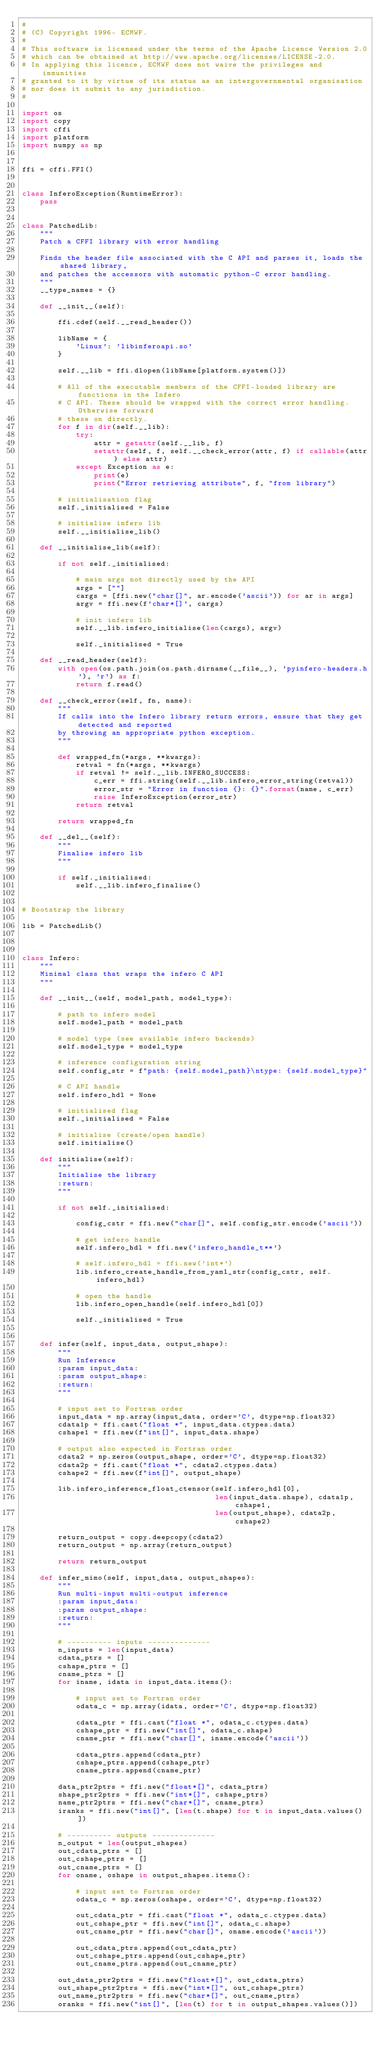<code> <loc_0><loc_0><loc_500><loc_500><_Python_>#
# (C) Copyright 1996- ECMWF.
#
# This software is licensed under the terms of the Apache Licence Version 2.0
# which can be obtained at http://www.apache.org/licenses/LICENSE-2.0.
# In applying this licence, ECMWF does not waive the privileges and immunities
# granted to it by virtue of its status as an intergovernmental organisation
# nor does it submit to any jurisdiction.
#

import os
import copy
import cffi
import platform
import numpy as np


ffi = cffi.FFI()


class InferoException(RuntimeError):
    pass


class PatchedLib:
    """
    Patch a CFFI library with error handling

    Finds the header file associated with the C API and parses it, loads the shared library,
    and patches the accessors with automatic python-C error handling.
    """
    __type_names = {}

    def __init__(self):

        ffi.cdef(self.__read_header())        

        libName = {
            'Linux': 'libinferoapi.so'
        }

        self.__lib = ffi.dlopen(libName[platform.system()])

        # All of the executable members of the CFFI-loaded library are functions in the Infero
        # C API. These should be wrapped with the correct error handling. Otherwise forward
        # these on directly.
        for f in dir(self.__lib):
            try:
                attr = getattr(self.__lib, f)
                setattr(self, f, self.__check_error(attr, f) if callable(attr) else attr)
            except Exception as e:
                print(e)
                print("Error retrieving attribute", f, "from library")

        # initialisation flag
        self._initialised = False

        # initialise infero lib
        self.__initialise_lib()

    def __initialise_lib(self):

        if not self._initialised:

            # main args not directly used by the API
            args = [""]
            cargs = [ffi.new("char[]", ar.encode('ascii')) for ar in args]
            argv = ffi.new(f'char*[]', cargs)

            # init infero lib
            self.__lib.infero_initialise(len(cargs), argv)

            self._initialised = True

    def __read_header(self):
        with open(os.path.join(os.path.dirname(__file__), 'pyinfero-headers.h'), 'r') as f:
            return f.read()

    def __check_error(self, fn, name):
        """
        If calls into the Infero library return errors, ensure that they get detected and reported
        by throwing an appropriate python exception.
        """

        def wrapped_fn(*args, **kwargs):
            retval = fn(*args, **kwargs)
            if retval != self.__lib.INFERO_SUCCESS:
                c_err = ffi.string(self.__lib.infero_error_string(retval))
                error_str = "Error in function {}: {}".format(name, c_err)
                raise InferoException(error_str)
            return retval

        return wrapped_fn

    def __del__(self):
        """
        Finalise infero lib
        """

        if self._initialised:
            self.__lib.infero_finalise()


# Bootstrap the library

lib = PatchedLib()



class Infero:
    """
    Minimal class that wraps the infero C API
    """

    def __init__(self, model_path, model_type):

        # path to infero model
        self.model_path = model_path

        # model type (see available infero backends)
        self.model_type = model_type

        # inference configuration string
        self.config_str = f"path: {self.model_path}\ntype: {self.model_type}"

        # C API handle
        self.infero_hdl = None  

        # initialised flag
        self._initialised = False

        # initialise (create/open handle)
        self.initialise()

    def initialise(self):
        """
        Initialise the library
        :return:
        """

        if not self._initialised:

            config_cstr = ffi.new("char[]", self.config_str.encode('ascii'))

            # get infero handle
            self.infero_hdl = ffi.new('infero_handle_t**')

            # self.infero_hdl = ffi.new('int*')
            lib.infero_create_handle_from_yaml_str(config_cstr, self.infero_hdl)

            # open the handle
            lib.infero_open_handle(self.infero_hdl[0])

            self._initialised = True


    def infer(self, input_data, output_shape):
        """
        Run Inference
        :param input_data:
        :param output_shape:
        :return:
        """

        # input set to Fortran order
        input_data = np.array(input_data, order='C', dtype=np.float32)
        cdata1p = ffi.cast("float *", input_data.ctypes.data)
        cshape1 = ffi.new(f"int[]", input_data.shape)

        # output also expected in Fortran order
        cdata2 = np.zeros(output_shape, order='C', dtype=np.float32)
        cdata2p = ffi.cast("float *", cdata2.ctypes.data)
        cshape2 = ffi.new(f"int[]", output_shape)

        lib.infero_inference_float_ctensor(self.infero_hdl[0],
                                           len(input_data.shape), cdata1p, cshape1,
                                           len(output_shape), cdata2p, cshape2)

        return_output = copy.deepcopy(cdata2)
        return_output = np.array(return_output)

        return return_output

    def infer_mimo(self, input_data, output_shapes):
        """
        Run multi-input multi-output inference
        :param input_data:
        :param output_shape:
        :return:
        """

        # ---------- inputs --------------
        n_inputs = len(input_data)
        cdata_ptrs = []
        cshape_ptrs = []
        cname_ptrs = []
        for iname, idata in input_data.items():

            # input set to Fortran order
            odata_c = np.array(idata, order='C', dtype=np.float32)

            cdata_ptr = ffi.cast("float *", odata_c.ctypes.data)
            cshape_ptr = ffi.new("int[]", odata_c.shape)
            cname_ptr = ffi.new("char[]", iname.encode('ascii'))

            cdata_ptrs.append(cdata_ptr)
            cshape_ptrs.append(cshape_ptr)
            cname_ptrs.append(cname_ptr)

        data_ptr2ptrs = ffi.new("float*[]", cdata_ptrs)
        shape_ptr2ptrs = ffi.new("int*[]", cshape_ptrs)
        name_ptr2ptrs = ffi.new("char*[]", cname_ptrs)
        iranks = ffi.new("int[]", [len(t.shape) for t in input_data.values()])

        # ---------- outputs --------------
        n_output = len(output_shapes)
        out_cdata_ptrs = []
        out_cshape_ptrs = []
        out_cname_ptrs = []
        for oname, oshape in output_shapes.items():

            # input set to Fortran order
            odata_c = np.zeros(oshape, order='C', dtype=np.float32)

            out_cdata_ptr = ffi.cast("float *", odata_c.ctypes.data)
            out_cshape_ptr = ffi.new("int[]", odata_c.shape)
            out_cname_ptr = ffi.new("char[]", oname.encode('ascii'))

            out_cdata_ptrs.append(out_cdata_ptr)
            out_cshape_ptrs.append(out_cshape_ptr)
            out_cname_ptrs.append(out_cname_ptr)

        out_data_ptr2ptrs = ffi.new("float*[]", out_cdata_ptrs)
        out_shape_ptr2ptrs = ffi.new("int*[]", out_cshape_ptrs)
        out_name_ptr2ptrs = ffi.new("char*[]", out_cname_ptrs)
        oranks = ffi.new("int[]", [len(t) for t in output_shapes.values()])
</code> 